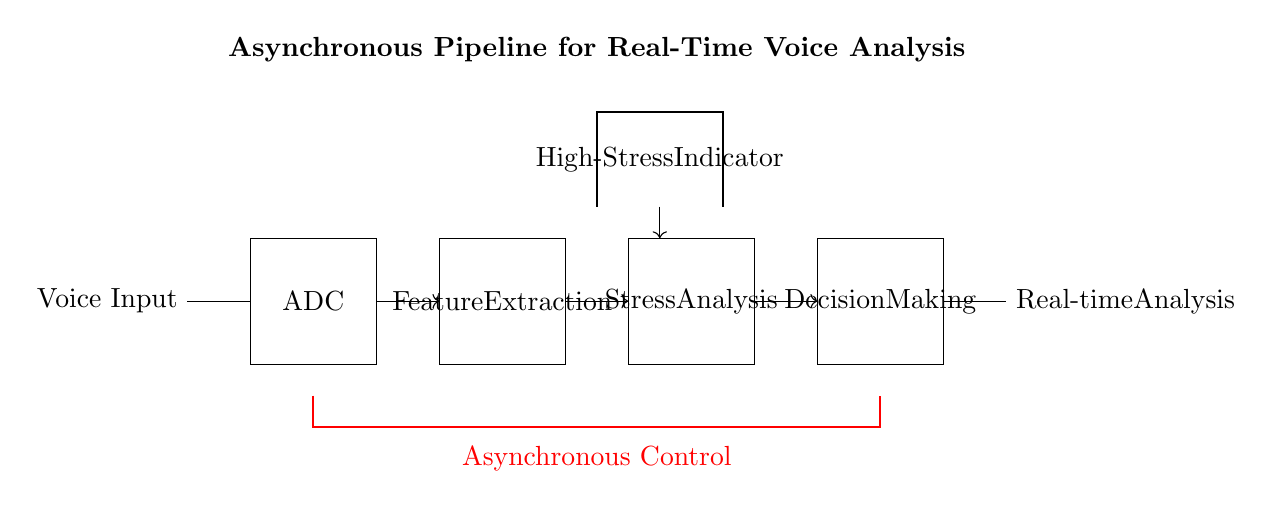What is the first component in the pipeline? The first component listed is the ADC, which is depicted in the diagram as the component following the voice input.
Answer: ADC What connects the ADC to the feature extraction stage? The connection is represented by an arrow going from the ADC to the feature extraction block, indicating the flow of data.
Answer: Arrow What color represents the asynchronous control line? The asynchronous control line is drawn in red, allowing for easy identification in the diagram.
Answer: Red How many main processing stages are depicted in the circuit? There are three main processing stages shown after the ADC, which include feature extraction, stress analysis, and decision making.
Answer: Three What does the high-stress indicator represent? The high-stress indicator is associated with the stress analysis stage, providing feedback on the detected stress levels during voice analysis.
Answer: High-Stress What type of control does this pipeline utilize? The pipeline utilizes asynchronous control, as indicated by the red thick line running beneath the processing stages.
Answer: Asynchronous 